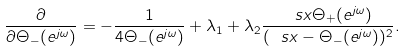Convert formula to latex. <formula><loc_0><loc_0><loc_500><loc_500>\frac { \partial \L } { \partial \Theta _ { - } ( e ^ { j \omega } ) } = - \frac { 1 } { 4 \Theta _ { - } ( e ^ { j \omega } ) } + \lambda _ { 1 } + \lambda _ { 2 } \frac { \ s x \Theta _ { + } ( e ^ { j \omega } ) } { ( \ s x - \Theta _ { - } ( e ^ { j \omega } ) ) ^ { 2 } } .</formula> 